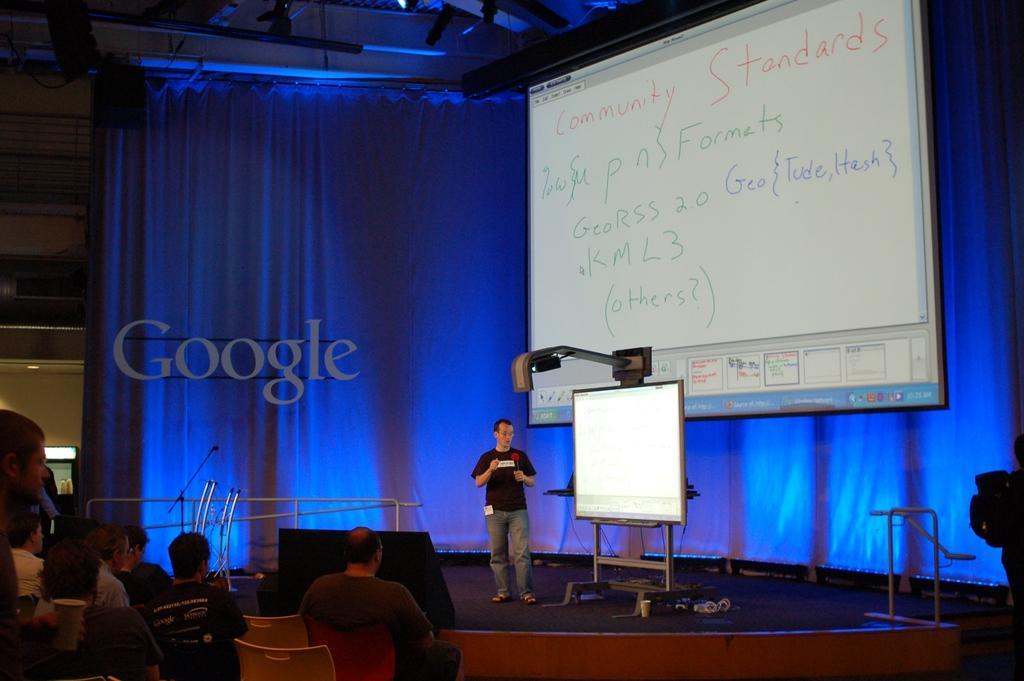How would you summarize this image in a sentence or two? In the center of the image there is a person standing at the screen on the dais. At the bottom of the image we can see crowd. In the background we can see curtain and screen. 